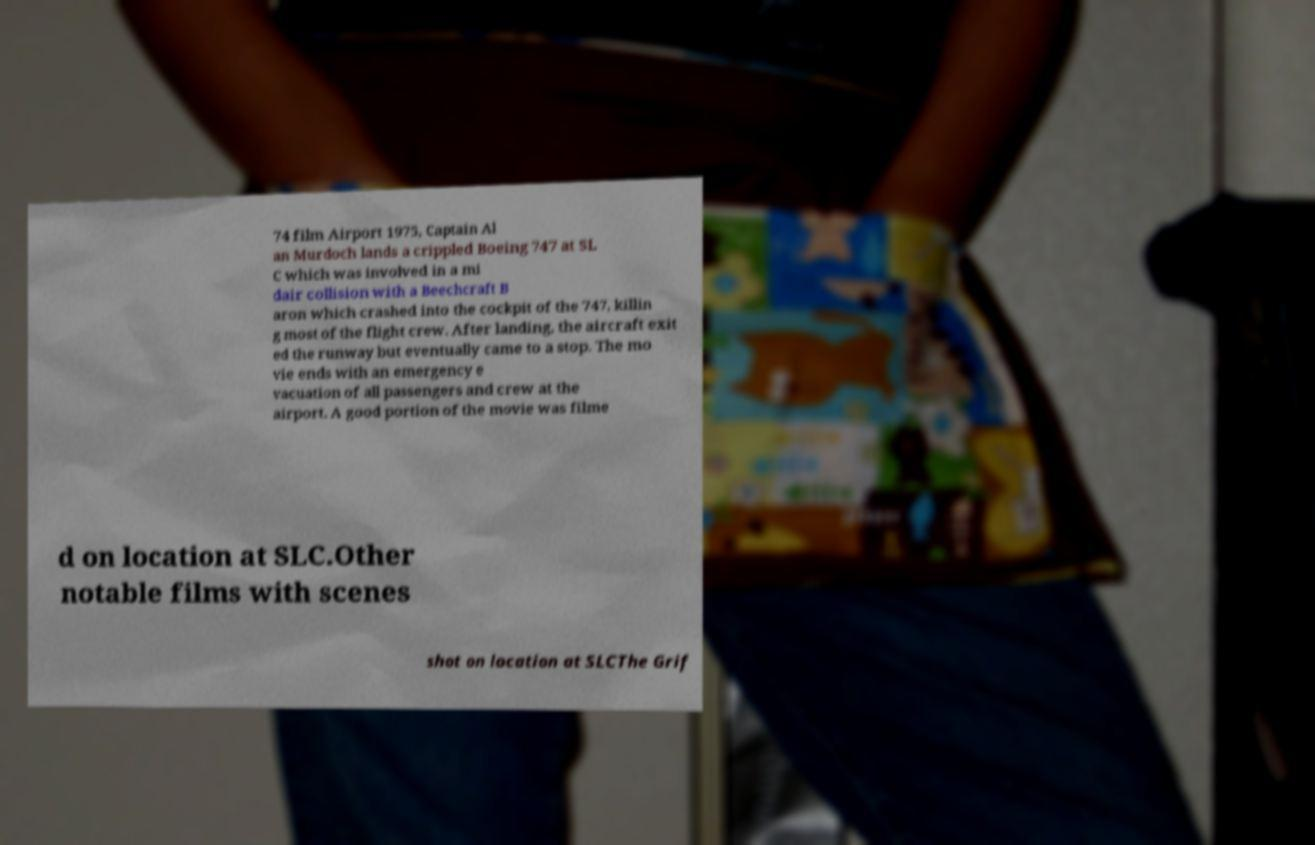Please read and relay the text visible in this image. What does it say? 74 film Airport 1975, Captain Al an Murdoch lands a crippled Boeing 747 at SL C which was involved in a mi dair collision with a Beechcraft B aron which crashed into the cockpit of the 747, killin g most of the flight crew. After landing, the aircraft exit ed the runway but eventually came to a stop. The mo vie ends with an emergency e vacuation of all passengers and crew at the airport. A good portion of the movie was filme d on location at SLC.Other notable films with scenes shot on location at SLCThe Grif 